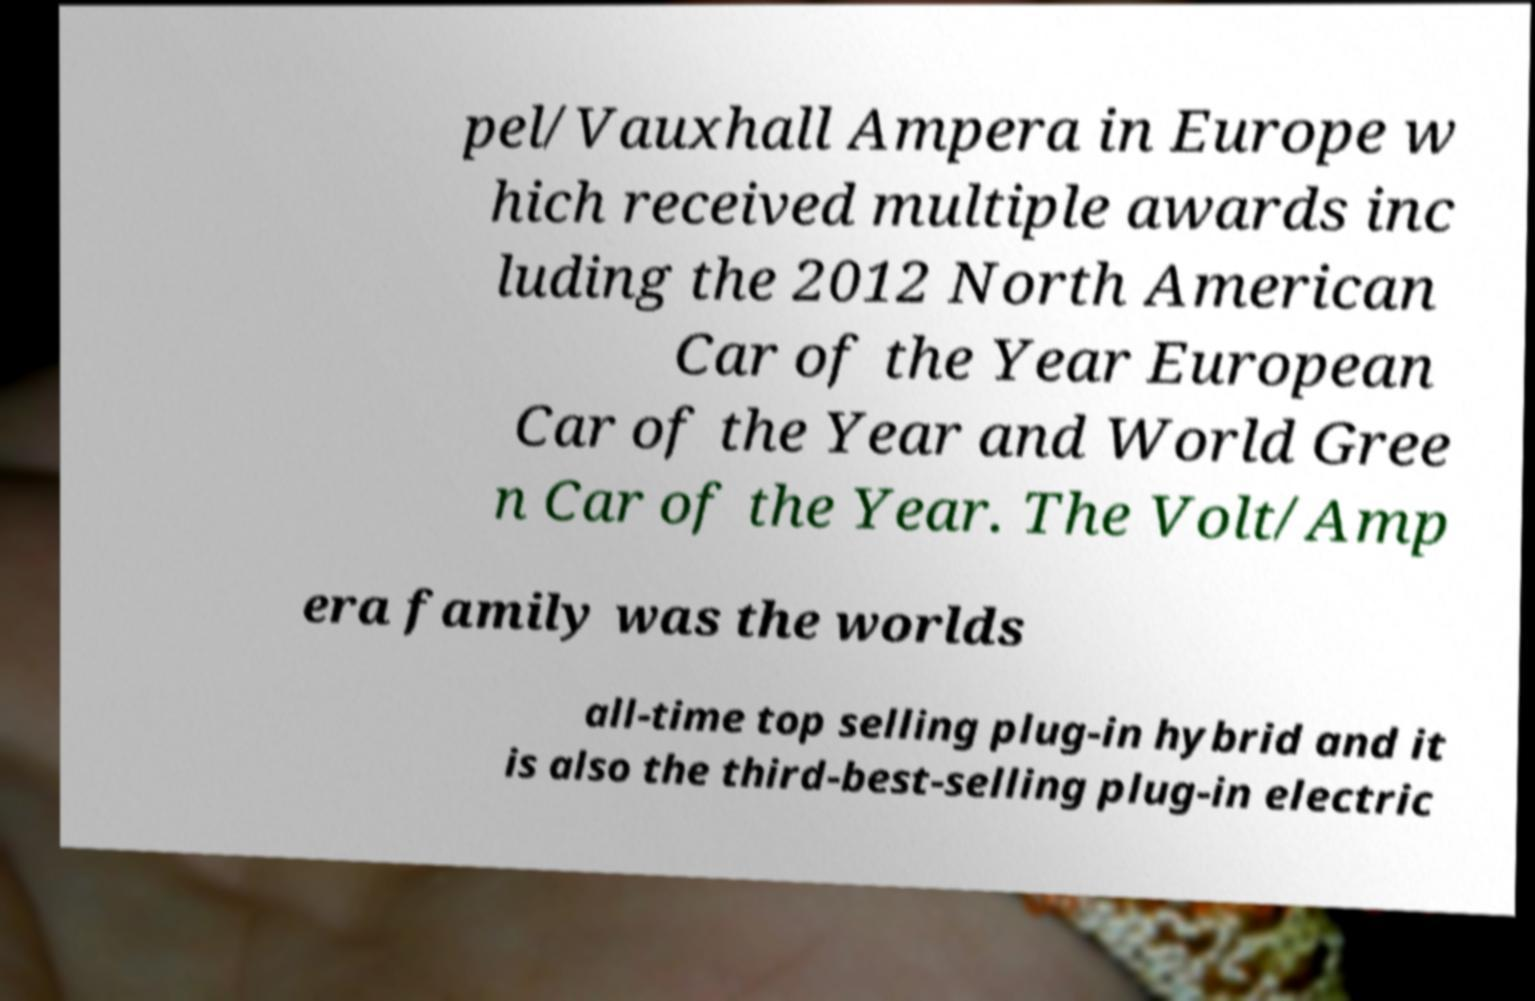Please identify and transcribe the text found in this image. pel/Vauxhall Ampera in Europe w hich received multiple awards inc luding the 2012 North American Car of the Year European Car of the Year and World Gree n Car of the Year. The Volt/Amp era family was the worlds all-time top selling plug-in hybrid and it is also the third-best-selling plug-in electric 